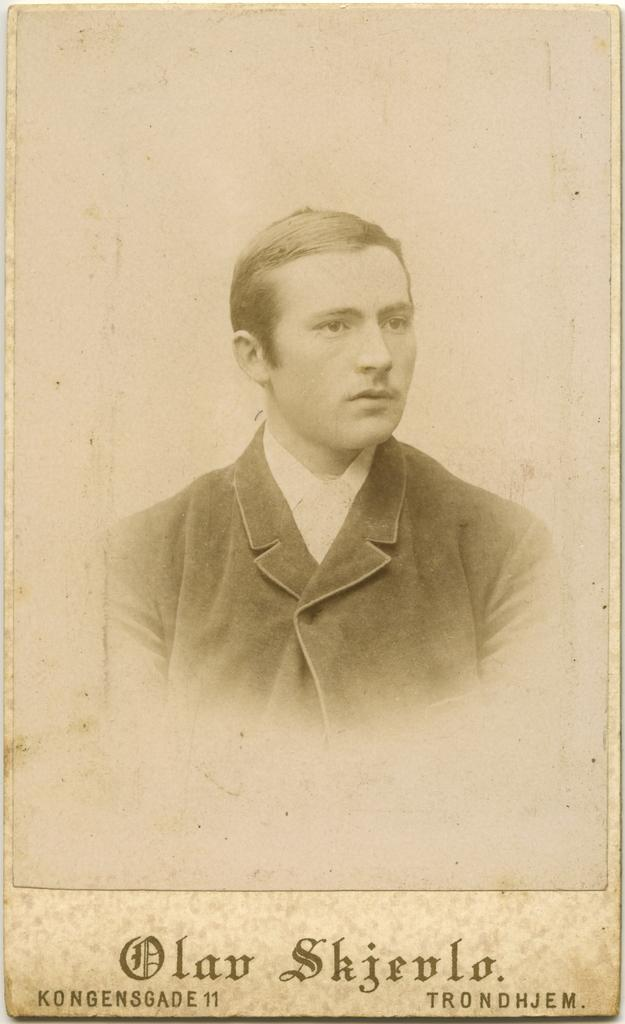What is present in the image that contains both an image and text? There is a poster in the image that contains both an image and text. What type of ear is depicted in the image? There is no ear present in the image; it only contains a poster with an image and text. 